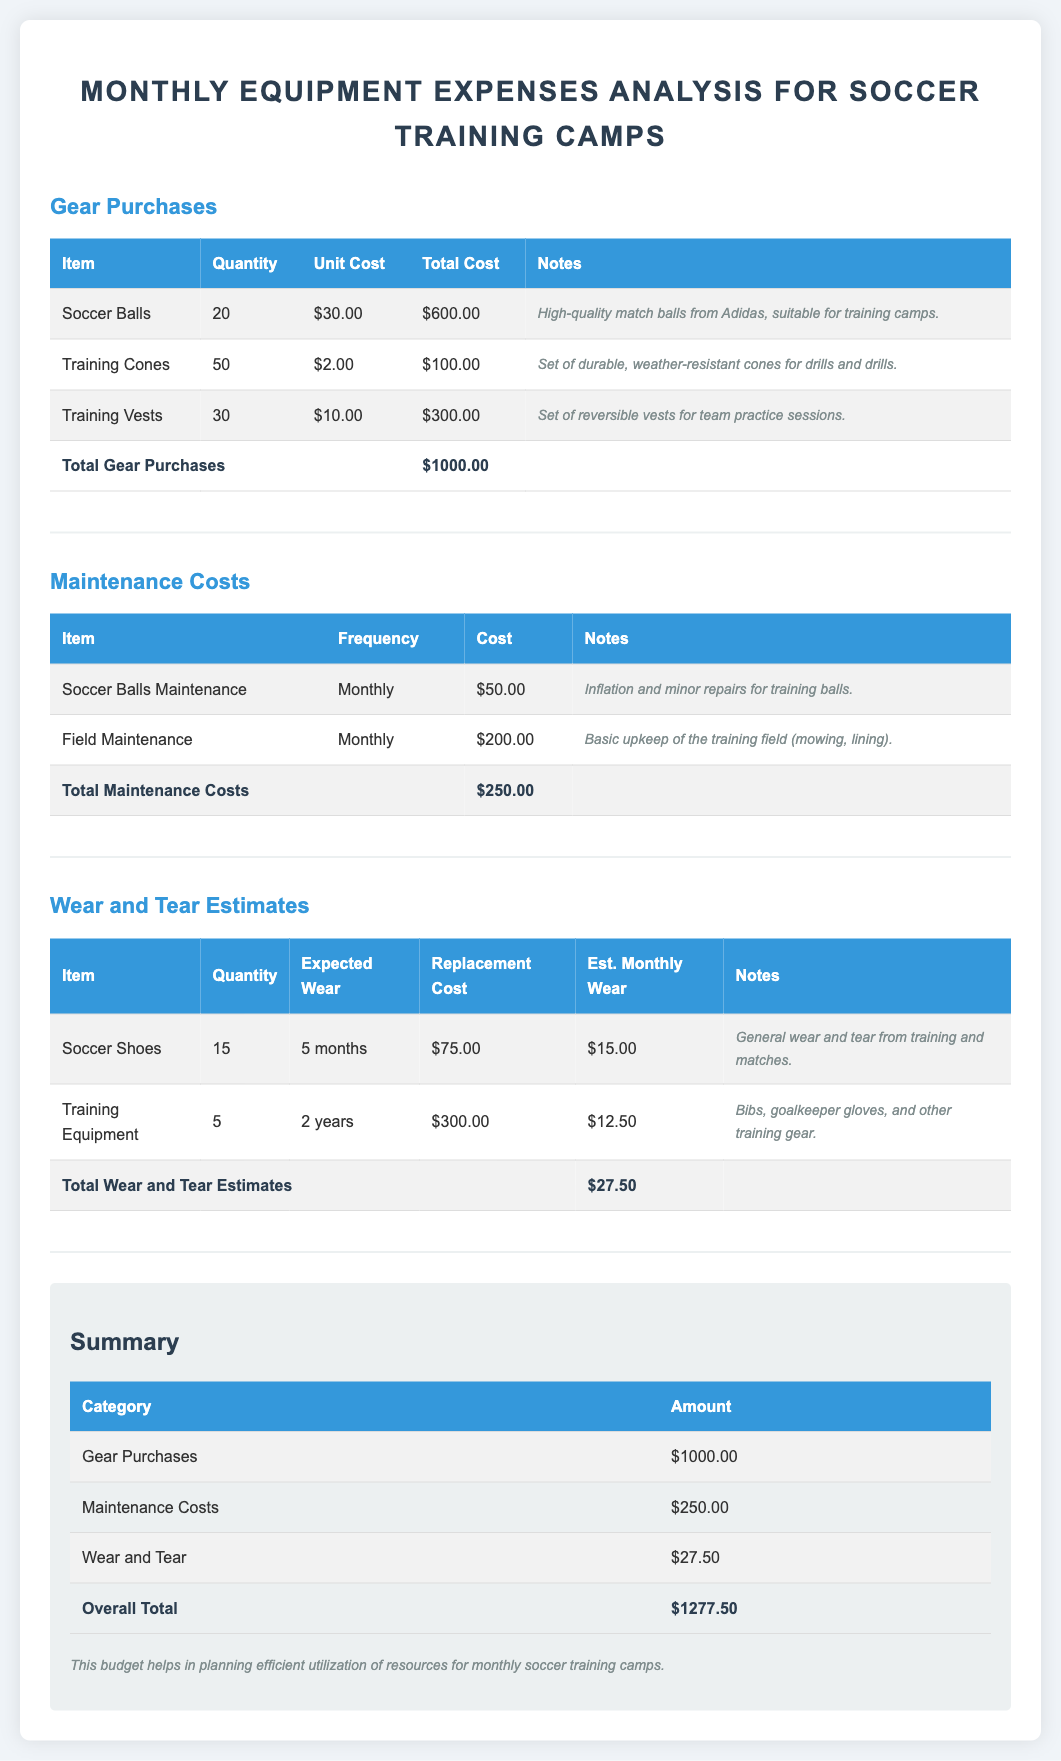What is the total cost of gear purchases? The total cost of gear purchases is listed at the bottom of the gear purchases section, which is $1000.00.
Answer: $1000.00 How many soccer balls were purchased? The quantity of soccer balls purchased is specified in the gear purchases table, which shows 20 soccer balls.
Answer: 20 What is the monthly cost for field maintenance? The cost for field maintenance can be found in the maintenance costs table, which lists it at $200.00.
Answer: $200.00 What is the expected wear and tear cost for soccer shoes? The expected wear and tear cost for soccer shoes is shown in the wear and tear estimates section as $15.00.
Answer: $15.00 What is the overall total for monthly equipment expenses? The overall total for all expenses is provided in the summary section of the document, which is $1277.50.
Answer: $1277.50 How often does soccer balls maintenance need to be performed? The frequency for soccer balls maintenance is specified in the maintenance costs table as monthly.
Answer: Monthly What is the unit cost of training cones? The unit cost of training cones is listed in the gear purchases section, which shows $2.00 per cone.
Answer: $2.00 What is the total of maintenance costs? The total of maintenance costs is summarized in the maintenance costs table as $250.00.
Answer: $250.00 How many training vests were acquired? The document states that 30 training vests were acquired in the gear purchases section.
Answer: 30 